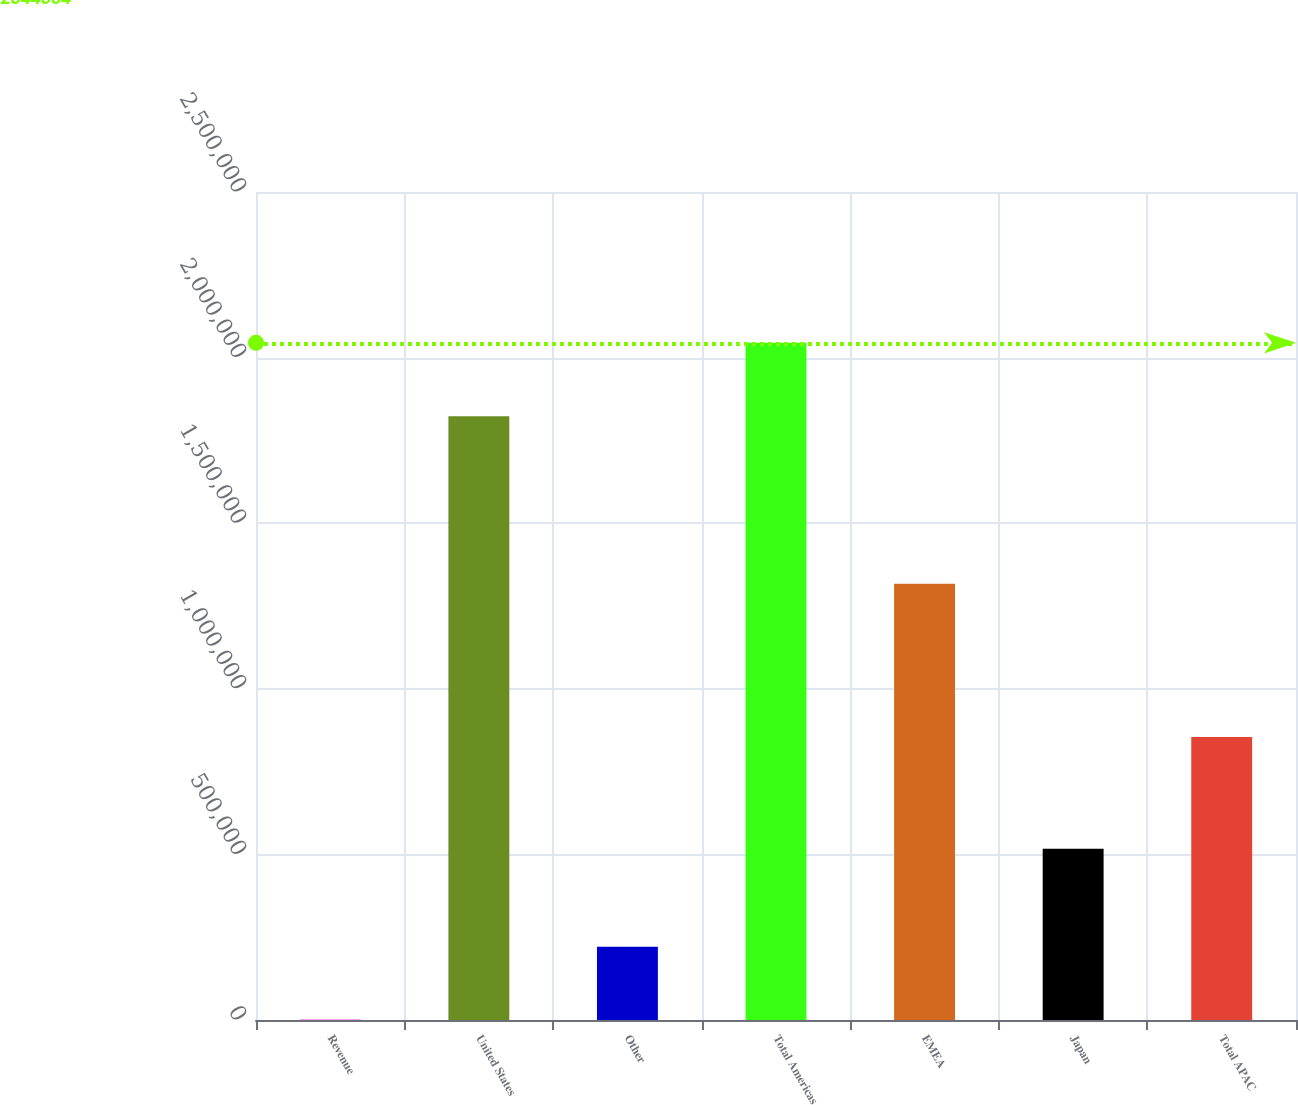Convert chart. <chart><loc_0><loc_0><loc_500><loc_500><bar_chart><fcel>Revenue<fcel>United States<fcel>Other<fcel>Total Americas<fcel>EMEA<fcel>Japan<fcel>Total APAC<nl><fcel>2011<fcel>1.8232e+06<fcel>221399<fcel>2.0446e+06<fcel>1.31742e+06<fcel>517378<fcel>854237<nl></chart> 